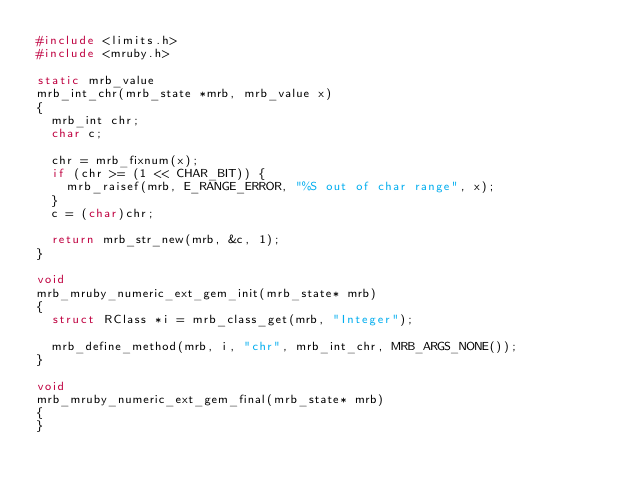Convert code to text. <code><loc_0><loc_0><loc_500><loc_500><_C_>#include <limits.h>
#include <mruby.h>

static mrb_value
mrb_int_chr(mrb_state *mrb, mrb_value x)
{
  mrb_int chr;
  char c;

  chr = mrb_fixnum(x);
  if (chr >= (1 << CHAR_BIT)) {
    mrb_raisef(mrb, E_RANGE_ERROR, "%S out of char range", x);
  }
  c = (char)chr;

  return mrb_str_new(mrb, &c, 1);
}

void
mrb_mruby_numeric_ext_gem_init(mrb_state* mrb)
{
  struct RClass *i = mrb_class_get(mrb, "Integer");

  mrb_define_method(mrb, i, "chr", mrb_int_chr, MRB_ARGS_NONE());
}

void
mrb_mruby_numeric_ext_gem_final(mrb_state* mrb)
{
}
</code> 